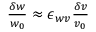<formula> <loc_0><loc_0><loc_500><loc_500>\begin{array} { r } { \frac { \delta w } { w _ { 0 } } \approx \epsilon _ { w v } \frac { \delta v } { v _ { 0 } } } \end{array}</formula> 